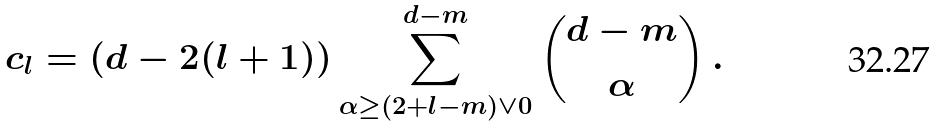Convert formula to latex. <formula><loc_0><loc_0><loc_500><loc_500>c _ { l } = ( d - 2 ( l + 1 ) ) \sum _ { \alpha \geq ( 2 + l - m ) \vee 0 } ^ { d - m } { d - m \choose \alpha } \, .</formula> 